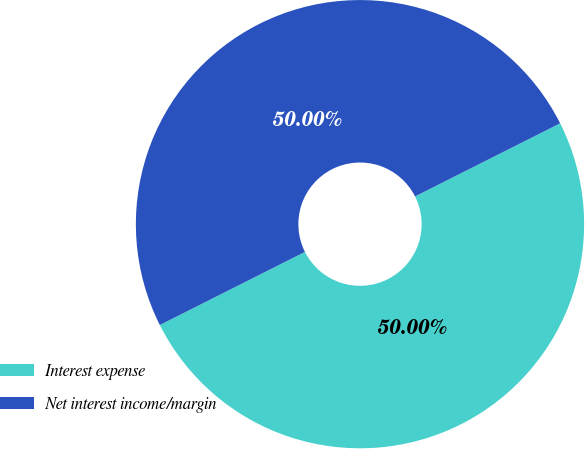Convert chart to OTSL. <chart><loc_0><loc_0><loc_500><loc_500><pie_chart><fcel>Interest expense<fcel>Net interest income/margin<nl><fcel>50.0%<fcel>50.0%<nl></chart> 